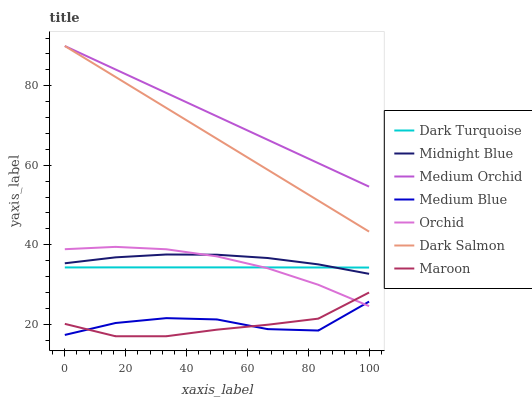Does Maroon have the minimum area under the curve?
Answer yes or no. Yes. Does Medium Orchid have the maximum area under the curve?
Answer yes or no. Yes. Does Dark Turquoise have the minimum area under the curve?
Answer yes or no. No. Does Dark Turquoise have the maximum area under the curve?
Answer yes or no. No. Is Medium Orchid the smoothest?
Answer yes or no. Yes. Is Medium Blue the roughest?
Answer yes or no. Yes. Is Dark Turquoise the smoothest?
Answer yes or no. No. Is Dark Turquoise the roughest?
Answer yes or no. No. Does Maroon have the lowest value?
Answer yes or no. Yes. Does Dark Turquoise have the lowest value?
Answer yes or no. No. Does Dark Salmon have the highest value?
Answer yes or no. Yes. Does Dark Turquoise have the highest value?
Answer yes or no. No. Is Medium Blue less than Dark Salmon?
Answer yes or no. Yes. Is Dark Salmon greater than Dark Turquoise?
Answer yes or no. Yes. Does Midnight Blue intersect Orchid?
Answer yes or no. Yes. Is Midnight Blue less than Orchid?
Answer yes or no. No. Is Midnight Blue greater than Orchid?
Answer yes or no. No. Does Medium Blue intersect Dark Salmon?
Answer yes or no. No. 